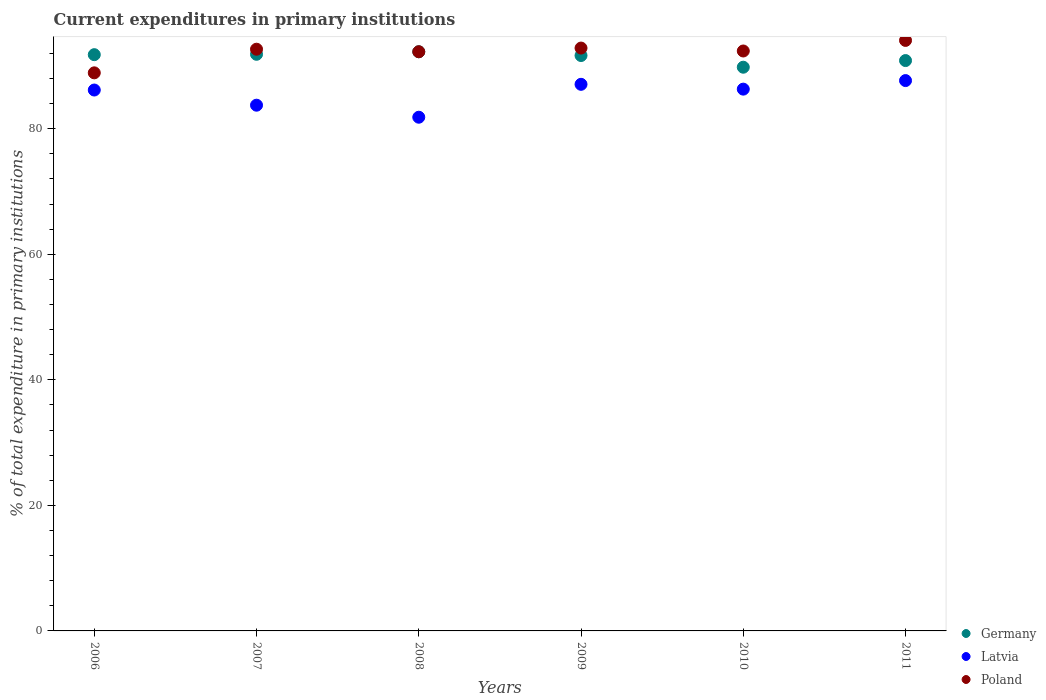Is the number of dotlines equal to the number of legend labels?
Give a very brief answer. Yes. What is the current expenditures in primary institutions in Germany in 2010?
Your answer should be very brief. 89.79. Across all years, what is the maximum current expenditures in primary institutions in Latvia?
Give a very brief answer. 87.66. Across all years, what is the minimum current expenditures in primary institutions in Poland?
Offer a very short reply. 88.89. What is the total current expenditures in primary institutions in Latvia in the graph?
Ensure brevity in your answer.  512.74. What is the difference between the current expenditures in primary institutions in Germany in 2010 and that in 2011?
Ensure brevity in your answer.  -1.06. What is the difference between the current expenditures in primary institutions in Poland in 2008 and the current expenditures in primary institutions in Latvia in 2009?
Provide a short and direct response. 5.19. What is the average current expenditures in primary institutions in Poland per year?
Offer a terse response. 92.18. In the year 2011, what is the difference between the current expenditures in primary institutions in Poland and current expenditures in primary institutions in Germany?
Your answer should be compact. 3.21. In how many years, is the current expenditures in primary institutions in Poland greater than 64 %?
Keep it short and to the point. 6. What is the ratio of the current expenditures in primary institutions in Germany in 2006 to that in 2008?
Offer a very short reply. 0.99. Is the difference between the current expenditures in primary institutions in Poland in 2006 and 2009 greater than the difference between the current expenditures in primary institutions in Germany in 2006 and 2009?
Keep it short and to the point. No. What is the difference between the highest and the second highest current expenditures in primary institutions in Latvia?
Your answer should be compact. 0.6. What is the difference between the highest and the lowest current expenditures in primary institutions in Poland?
Ensure brevity in your answer.  5.17. Is the sum of the current expenditures in primary institutions in Germany in 2006 and 2011 greater than the maximum current expenditures in primary institutions in Poland across all years?
Offer a very short reply. Yes. Does the current expenditures in primary institutions in Latvia monotonically increase over the years?
Make the answer very short. No. How many dotlines are there?
Your response must be concise. 3. What is the difference between two consecutive major ticks on the Y-axis?
Provide a succinct answer. 20. Where does the legend appear in the graph?
Give a very brief answer. Bottom right. How many legend labels are there?
Keep it short and to the point. 3. How are the legend labels stacked?
Offer a very short reply. Vertical. What is the title of the graph?
Offer a terse response. Current expenditures in primary institutions. What is the label or title of the Y-axis?
Offer a terse response. % of total expenditure in primary institutions. What is the % of total expenditure in primary institutions of Germany in 2006?
Your answer should be compact. 91.79. What is the % of total expenditure in primary institutions in Latvia in 2006?
Provide a succinct answer. 86.16. What is the % of total expenditure in primary institutions in Poland in 2006?
Offer a very short reply. 88.89. What is the % of total expenditure in primary institutions in Germany in 2007?
Provide a short and direct response. 91.85. What is the % of total expenditure in primary institutions of Latvia in 2007?
Keep it short and to the point. 83.74. What is the % of total expenditure in primary institutions in Poland in 2007?
Your answer should be compact. 92.66. What is the % of total expenditure in primary institutions of Germany in 2008?
Keep it short and to the point. 92.25. What is the % of total expenditure in primary institutions of Latvia in 2008?
Offer a very short reply. 81.82. What is the % of total expenditure in primary institutions of Poland in 2008?
Offer a terse response. 92.25. What is the % of total expenditure in primary institutions of Germany in 2009?
Provide a succinct answer. 91.65. What is the % of total expenditure in primary institutions in Latvia in 2009?
Offer a terse response. 87.06. What is the % of total expenditure in primary institutions in Poland in 2009?
Provide a succinct answer. 92.84. What is the % of total expenditure in primary institutions in Germany in 2010?
Your answer should be compact. 89.79. What is the % of total expenditure in primary institutions in Latvia in 2010?
Provide a short and direct response. 86.3. What is the % of total expenditure in primary institutions in Poland in 2010?
Ensure brevity in your answer.  92.37. What is the % of total expenditure in primary institutions of Germany in 2011?
Make the answer very short. 90.85. What is the % of total expenditure in primary institutions of Latvia in 2011?
Keep it short and to the point. 87.66. What is the % of total expenditure in primary institutions of Poland in 2011?
Provide a succinct answer. 94.06. Across all years, what is the maximum % of total expenditure in primary institutions of Germany?
Your answer should be compact. 92.25. Across all years, what is the maximum % of total expenditure in primary institutions in Latvia?
Offer a very short reply. 87.66. Across all years, what is the maximum % of total expenditure in primary institutions in Poland?
Your response must be concise. 94.06. Across all years, what is the minimum % of total expenditure in primary institutions of Germany?
Give a very brief answer. 89.79. Across all years, what is the minimum % of total expenditure in primary institutions in Latvia?
Offer a terse response. 81.82. Across all years, what is the minimum % of total expenditure in primary institutions of Poland?
Give a very brief answer. 88.89. What is the total % of total expenditure in primary institutions in Germany in the graph?
Offer a terse response. 548.17. What is the total % of total expenditure in primary institutions of Latvia in the graph?
Ensure brevity in your answer.  512.74. What is the total % of total expenditure in primary institutions in Poland in the graph?
Provide a succinct answer. 553.07. What is the difference between the % of total expenditure in primary institutions in Germany in 2006 and that in 2007?
Your response must be concise. -0.06. What is the difference between the % of total expenditure in primary institutions of Latvia in 2006 and that in 2007?
Keep it short and to the point. 2.42. What is the difference between the % of total expenditure in primary institutions of Poland in 2006 and that in 2007?
Provide a succinct answer. -3.76. What is the difference between the % of total expenditure in primary institutions in Germany in 2006 and that in 2008?
Give a very brief answer. -0.46. What is the difference between the % of total expenditure in primary institutions in Latvia in 2006 and that in 2008?
Provide a short and direct response. 4.33. What is the difference between the % of total expenditure in primary institutions in Poland in 2006 and that in 2008?
Offer a terse response. -3.36. What is the difference between the % of total expenditure in primary institutions of Germany in 2006 and that in 2009?
Your response must be concise. 0.14. What is the difference between the % of total expenditure in primary institutions of Latvia in 2006 and that in 2009?
Offer a very short reply. -0.91. What is the difference between the % of total expenditure in primary institutions of Poland in 2006 and that in 2009?
Make the answer very short. -3.95. What is the difference between the % of total expenditure in primary institutions of Germany in 2006 and that in 2010?
Your answer should be compact. 2. What is the difference between the % of total expenditure in primary institutions in Latvia in 2006 and that in 2010?
Your response must be concise. -0.14. What is the difference between the % of total expenditure in primary institutions in Poland in 2006 and that in 2010?
Ensure brevity in your answer.  -3.48. What is the difference between the % of total expenditure in primary institutions in Germany in 2006 and that in 2011?
Your answer should be compact. 0.94. What is the difference between the % of total expenditure in primary institutions in Latvia in 2006 and that in 2011?
Keep it short and to the point. -1.5. What is the difference between the % of total expenditure in primary institutions in Poland in 2006 and that in 2011?
Offer a very short reply. -5.17. What is the difference between the % of total expenditure in primary institutions of Germany in 2007 and that in 2008?
Give a very brief answer. -0.4. What is the difference between the % of total expenditure in primary institutions of Latvia in 2007 and that in 2008?
Ensure brevity in your answer.  1.92. What is the difference between the % of total expenditure in primary institutions of Poland in 2007 and that in 2008?
Make the answer very short. 0.4. What is the difference between the % of total expenditure in primary institutions in Germany in 2007 and that in 2009?
Give a very brief answer. 0.2. What is the difference between the % of total expenditure in primary institutions in Latvia in 2007 and that in 2009?
Provide a short and direct response. -3.32. What is the difference between the % of total expenditure in primary institutions of Poland in 2007 and that in 2009?
Give a very brief answer. -0.18. What is the difference between the % of total expenditure in primary institutions of Germany in 2007 and that in 2010?
Keep it short and to the point. 2.06. What is the difference between the % of total expenditure in primary institutions of Latvia in 2007 and that in 2010?
Ensure brevity in your answer.  -2.56. What is the difference between the % of total expenditure in primary institutions of Poland in 2007 and that in 2010?
Your response must be concise. 0.28. What is the difference between the % of total expenditure in primary institutions in Latvia in 2007 and that in 2011?
Offer a very short reply. -3.92. What is the difference between the % of total expenditure in primary institutions of Poland in 2007 and that in 2011?
Provide a short and direct response. -1.4. What is the difference between the % of total expenditure in primary institutions of Germany in 2008 and that in 2009?
Provide a succinct answer. 0.6. What is the difference between the % of total expenditure in primary institutions of Latvia in 2008 and that in 2009?
Offer a very short reply. -5.24. What is the difference between the % of total expenditure in primary institutions in Poland in 2008 and that in 2009?
Your answer should be compact. -0.58. What is the difference between the % of total expenditure in primary institutions in Germany in 2008 and that in 2010?
Your response must be concise. 2.46. What is the difference between the % of total expenditure in primary institutions of Latvia in 2008 and that in 2010?
Provide a succinct answer. -4.47. What is the difference between the % of total expenditure in primary institutions of Poland in 2008 and that in 2010?
Provide a short and direct response. -0.12. What is the difference between the % of total expenditure in primary institutions of Germany in 2008 and that in 2011?
Your answer should be compact. 1.4. What is the difference between the % of total expenditure in primary institutions of Latvia in 2008 and that in 2011?
Provide a short and direct response. -5.84. What is the difference between the % of total expenditure in primary institutions of Poland in 2008 and that in 2011?
Provide a short and direct response. -1.8. What is the difference between the % of total expenditure in primary institutions of Germany in 2009 and that in 2010?
Provide a succinct answer. 1.86. What is the difference between the % of total expenditure in primary institutions of Latvia in 2009 and that in 2010?
Offer a terse response. 0.77. What is the difference between the % of total expenditure in primary institutions of Poland in 2009 and that in 2010?
Give a very brief answer. 0.47. What is the difference between the % of total expenditure in primary institutions of Germany in 2009 and that in 2011?
Ensure brevity in your answer.  0.8. What is the difference between the % of total expenditure in primary institutions of Latvia in 2009 and that in 2011?
Provide a short and direct response. -0.6. What is the difference between the % of total expenditure in primary institutions of Poland in 2009 and that in 2011?
Offer a very short reply. -1.22. What is the difference between the % of total expenditure in primary institutions of Germany in 2010 and that in 2011?
Offer a terse response. -1.06. What is the difference between the % of total expenditure in primary institutions in Latvia in 2010 and that in 2011?
Make the answer very short. -1.36. What is the difference between the % of total expenditure in primary institutions in Poland in 2010 and that in 2011?
Give a very brief answer. -1.69. What is the difference between the % of total expenditure in primary institutions of Germany in 2006 and the % of total expenditure in primary institutions of Latvia in 2007?
Provide a short and direct response. 8.05. What is the difference between the % of total expenditure in primary institutions in Germany in 2006 and the % of total expenditure in primary institutions in Poland in 2007?
Provide a succinct answer. -0.87. What is the difference between the % of total expenditure in primary institutions in Latvia in 2006 and the % of total expenditure in primary institutions in Poland in 2007?
Your answer should be very brief. -6.5. What is the difference between the % of total expenditure in primary institutions of Germany in 2006 and the % of total expenditure in primary institutions of Latvia in 2008?
Give a very brief answer. 9.96. What is the difference between the % of total expenditure in primary institutions of Germany in 2006 and the % of total expenditure in primary institutions of Poland in 2008?
Make the answer very short. -0.47. What is the difference between the % of total expenditure in primary institutions in Latvia in 2006 and the % of total expenditure in primary institutions in Poland in 2008?
Provide a short and direct response. -6.1. What is the difference between the % of total expenditure in primary institutions in Germany in 2006 and the % of total expenditure in primary institutions in Latvia in 2009?
Your response must be concise. 4.72. What is the difference between the % of total expenditure in primary institutions in Germany in 2006 and the % of total expenditure in primary institutions in Poland in 2009?
Provide a succinct answer. -1.05. What is the difference between the % of total expenditure in primary institutions in Latvia in 2006 and the % of total expenditure in primary institutions in Poland in 2009?
Provide a succinct answer. -6.68. What is the difference between the % of total expenditure in primary institutions of Germany in 2006 and the % of total expenditure in primary institutions of Latvia in 2010?
Offer a very short reply. 5.49. What is the difference between the % of total expenditure in primary institutions of Germany in 2006 and the % of total expenditure in primary institutions of Poland in 2010?
Your answer should be compact. -0.59. What is the difference between the % of total expenditure in primary institutions of Latvia in 2006 and the % of total expenditure in primary institutions of Poland in 2010?
Your answer should be compact. -6.22. What is the difference between the % of total expenditure in primary institutions of Germany in 2006 and the % of total expenditure in primary institutions of Latvia in 2011?
Make the answer very short. 4.13. What is the difference between the % of total expenditure in primary institutions in Germany in 2006 and the % of total expenditure in primary institutions in Poland in 2011?
Keep it short and to the point. -2.27. What is the difference between the % of total expenditure in primary institutions in Latvia in 2006 and the % of total expenditure in primary institutions in Poland in 2011?
Offer a terse response. -7.9. What is the difference between the % of total expenditure in primary institutions in Germany in 2007 and the % of total expenditure in primary institutions in Latvia in 2008?
Your response must be concise. 10.02. What is the difference between the % of total expenditure in primary institutions in Germany in 2007 and the % of total expenditure in primary institutions in Poland in 2008?
Your answer should be very brief. -0.41. What is the difference between the % of total expenditure in primary institutions in Latvia in 2007 and the % of total expenditure in primary institutions in Poland in 2008?
Give a very brief answer. -8.51. What is the difference between the % of total expenditure in primary institutions of Germany in 2007 and the % of total expenditure in primary institutions of Latvia in 2009?
Offer a very short reply. 4.78. What is the difference between the % of total expenditure in primary institutions of Germany in 2007 and the % of total expenditure in primary institutions of Poland in 2009?
Offer a terse response. -0.99. What is the difference between the % of total expenditure in primary institutions of Latvia in 2007 and the % of total expenditure in primary institutions of Poland in 2009?
Offer a terse response. -9.1. What is the difference between the % of total expenditure in primary institutions in Germany in 2007 and the % of total expenditure in primary institutions in Latvia in 2010?
Provide a short and direct response. 5.55. What is the difference between the % of total expenditure in primary institutions of Germany in 2007 and the % of total expenditure in primary institutions of Poland in 2010?
Make the answer very short. -0.52. What is the difference between the % of total expenditure in primary institutions in Latvia in 2007 and the % of total expenditure in primary institutions in Poland in 2010?
Offer a terse response. -8.63. What is the difference between the % of total expenditure in primary institutions in Germany in 2007 and the % of total expenditure in primary institutions in Latvia in 2011?
Provide a succinct answer. 4.19. What is the difference between the % of total expenditure in primary institutions of Germany in 2007 and the % of total expenditure in primary institutions of Poland in 2011?
Give a very brief answer. -2.21. What is the difference between the % of total expenditure in primary institutions in Latvia in 2007 and the % of total expenditure in primary institutions in Poland in 2011?
Your answer should be very brief. -10.32. What is the difference between the % of total expenditure in primary institutions in Germany in 2008 and the % of total expenditure in primary institutions in Latvia in 2009?
Provide a short and direct response. 5.19. What is the difference between the % of total expenditure in primary institutions of Germany in 2008 and the % of total expenditure in primary institutions of Poland in 2009?
Offer a very short reply. -0.59. What is the difference between the % of total expenditure in primary institutions of Latvia in 2008 and the % of total expenditure in primary institutions of Poland in 2009?
Provide a short and direct response. -11.01. What is the difference between the % of total expenditure in primary institutions in Germany in 2008 and the % of total expenditure in primary institutions in Latvia in 2010?
Your response must be concise. 5.96. What is the difference between the % of total expenditure in primary institutions in Germany in 2008 and the % of total expenditure in primary institutions in Poland in 2010?
Your response must be concise. -0.12. What is the difference between the % of total expenditure in primary institutions in Latvia in 2008 and the % of total expenditure in primary institutions in Poland in 2010?
Give a very brief answer. -10.55. What is the difference between the % of total expenditure in primary institutions of Germany in 2008 and the % of total expenditure in primary institutions of Latvia in 2011?
Offer a terse response. 4.59. What is the difference between the % of total expenditure in primary institutions of Germany in 2008 and the % of total expenditure in primary institutions of Poland in 2011?
Give a very brief answer. -1.81. What is the difference between the % of total expenditure in primary institutions of Latvia in 2008 and the % of total expenditure in primary institutions of Poland in 2011?
Provide a succinct answer. -12.23. What is the difference between the % of total expenditure in primary institutions in Germany in 2009 and the % of total expenditure in primary institutions in Latvia in 2010?
Offer a terse response. 5.35. What is the difference between the % of total expenditure in primary institutions in Germany in 2009 and the % of total expenditure in primary institutions in Poland in 2010?
Offer a terse response. -0.72. What is the difference between the % of total expenditure in primary institutions of Latvia in 2009 and the % of total expenditure in primary institutions of Poland in 2010?
Provide a short and direct response. -5.31. What is the difference between the % of total expenditure in primary institutions in Germany in 2009 and the % of total expenditure in primary institutions in Latvia in 2011?
Keep it short and to the point. 3.99. What is the difference between the % of total expenditure in primary institutions of Germany in 2009 and the % of total expenditure in primary institutions of Poland in 2011?
Make the answer very short. -2.41. What is the difference between the % of total expenditure in primary institutions in Latvia in 2009 and the % of total expenditure in primary institutions in Poland in 2011?
Your response must be concise. -6.99. What is the difference between the % of total expenditure in primary institutions of Germany in 2010 and the % of total expenditure in primary institutions of Latvia in 2011?
Provide a succinct answer. 2.13. What is the difference between the % of total expenditure in primary institutions in Germany in 2010 and the % of total expenditure in primary institutions in Poland in 2011?
Make the answer very short. -4.27. What is the difference between the % of total expenditure in primary institutions in Latvia in 2010 and the % of total expenditure in primary institutions in Poland in 2011?
Make the answer very short. -7.76. What is the average % of total expenditure in primary institutions in Germany per year?
Provide a succinct answer. 91.36. What is the average % of total expenditure in primary institutions of Latvia per year?
Make the answer very short. 85.46. What is the average % of total expenditure in primary institutions of Poland per year?
Your response must be concise. 92.18. In the year 2006, what is the difference between the % of total expenditure in primary institutions of Germany and % of total expenditure in primary institutions of Latvia?
Offer a terse response. 5.63. In the year 2006, what is the difference between the % of total expenditure in primary institutions of Germany and % of total expenditure in primary institutions of Poland?
Ensure brevity in your answer.  2.89. In the year 2006, what is the difference between the % of total expenditure in primary institutions of Latvia and % of total expenditure in primary institutions of Poland?
Make the answer very short. -2.74. In the year 2007, what is the difference between the % of total expenditure in primary institutions of Germany and % of total expenditure in primary institutions of Latvia?
Offer a very short reply. 8.11. In the year 2007, what is the difference between the % of total expenditure in primary institutions of Germany and % of total expenditure in primary institutions of Poland?
Keep it short and to the point. -0.81. In the year 2007, what is the difference between the % of total expenditure in primary institutions in Latvia and % of total expenditure in primary institutions in Poland?
Offer a very short reply. -8.92. In the year 2008, what is the difference between the % of total expenditure in primary institutions in Germany and % of total expenditure in primary institutions in Latvia?
Give a very brief answer. 10.43. In the year 2008, what is the difference between the % of total expenditure in primary institutions in Germany and % of total expenditure in primary institutions in Poland?
Make the answer very short. -0. In the year 2008, what is the difference between the % of total expenditure in primary institutions in Latvia and % of total expenditure in primary institutions in Poland?
Your answer should be compact. -10.43. In the year 2009, what is the difference between the % of total expenditure in primary institutions in Germany and % of total expenditure in primary institutions in Latvia?
Offer a very short reply. 4.59. In the year 2009, what is the difference between the % of total expenditure in primary institutions in Germany and % of total expenditure in primary institutions in Poland?
Provide a short and direct response. -1.19. In the year 2009, what is the difference between the % of total expenditure in primary institutions in Latvia and % of total expenditure in primary institutions in Poland?
Keep it short and to the point. -5.77. In the year 2010, what is the difference between the % of total expenditure in primary institutions of Germany and % of total expenditure in primary institutions of Latvia?
Provide a short and direct response. 3.49. In the year 2010, what is the difference between the % of total expenditure in primary institutions in Germany and % of total expenditure in primary institutions in Poland?
Your answer should be very brief. -2.58. In the year 2010, what is the difference between the % of total expenditure in primary institutions of Latvia and % of total expenditure in primary institutions of Poland?
Your response must be concise. -6.08. In the year 2011, what is the difference between the % of total expenditure in primary institutions of Germany and % of total expenditure in primary institutions of Latvia?
Offer a very short reply. 3.19. In the year 2011, what is the difference between the % of total expenditure in primary institutions of Germany and % of total expenditure in primary institutions of Poland?
Make the answer very short. -3.21. In the year 2011, what is the difference between the % of total expenditure in primary institutions in Latvia and % of total expenditure in primary institutions in Poland?
Your answer should be very brief. -6.4. What is the ratio of the % of total expenditure in primary institutions in Germany in 2006 to that in 2007?
Offer a terse response. 1. What is the ratio of the % of total expenditure in primary institutions in Latvia in 2006 to that in 2007?
Keep it short and to the point. 1.03. What is the ratio of the % of total expenditure in primary institutions of Poland in 2006 to that in 2007?
Your answer should be very brief. 0.96. What is the ratio of the % of total expenditure in primary institutions of Germany in 2006 to that in 2008?
Your response must be concise. 0.99. What is the ratio of the % of total expenditure in primary institutions in Latvia in 2006 to that in 2008?
Offer a terse response. 1.05. What is the ratio of the % of total expenditure in primary institutions of Poland in 2006 to that in 2008?
Your response must be concise. 0.96. What is the ratio of the % of total expenditure in primary institutions in Germany in 2006 to that in 2009?
Your response must be concise. 1. What is the ratio of the % of total expenditure in primary institutions of Poland in 2006 to that in 2009?
Provide a succinct answer. 0.96. What is the ratio of the % of total expenditure in primary institutions of Germany in 2006 to that in 2010?
Provide a succinct answer. 1.02. What is the ratio of the % of total expenditure in primary institutions of Poland in 2006 to that in 2010?
Give a very brief answer. 0.96. What is the ratio of the % of total expenditure in primary institutions in Germany in 2006 to that in 2011?
Keep it short and to the point. 1.01. What is the ratio of the % of total expenditure in primary institutions in Latvia in 2006 to that in 2011?
Your response must be concise. 0.98. What is the ratio of the % of total expenditure in primary institutions in Poland in 2006 to that in 2011?
Make the answer very short. 0.95. What is the ratio of the % of total expenditure in primary institutions of Germany in 2007 to that in 2008?
Keep it short and to the point. 1. What is the ratio of the % of total expenditure in primary institutions of Latvia in 2007 to that in 2008?
Provide a short and direct response. 1.02. What is the ratio of the % of total expenditure in primary institutions in Poland in 2007 to that in 2008?
Make the answer very short. 1. What is the ratio of the % of total expenditure in primary institutions of Latvia in 2007 to that in 2009?
Make the answer very short. 0.96. What is the ratio of the % of total expenditure in primary institutions in Germany in 2007 to that in 2010?
Your answer should be compact. 1.02. What is the ratio of the % of total expenditure in primary institutions of Latvia in 2007 to that in 2010?
Your answer should be very brief. 0.97. What is the ratio of the % of total expenditure in primary institutions in Germany in 2007 to that in 2011?
Your answer should be compact. 1.01. What is the ratio of the % of total expenditure in primary institutions in Latvia in 2007 to that in 2011?
Your answer should be very brief. 0.96. What is the ratio of the % of total expenditure in primary institutions in Poland in 2007 to that in 2011?
Provide a short and direct response. 0.99. What is the ratio of the % of total expenditure in primary institutions of Germany in 2008 to that in 2009?
Provide a succinct answer. 1.01. What is the ratio of the % of total expenditure in primary institutions of Latvia in 2008 to that in 2009?
Your answer should be compact. 0.94. What is the ratio of the % of total expenditure in primary institutions in Poland in 2008 to that in 2009?
Offer a very short reply. 0.99. What is the ratio of the % of total expenditure in primary institutions in Germany in 2008 to that in 2010?
Give a very brief answer. 1.03. What is the ratio of the % of total expenditure in primary institutions in Latvia in 2008 to that in 2010?
Provide a succinct answer. 0.95. What is the ratio of the % of total expenditure in primary institutions of Germany in 2008 to that in 2011?
Make the answer very short. 1.02. What is the ratio of the % of total expenditure in primary institutions in Latvia in 2008 to that in 2011?
Give a very brief answer. 0.93. What is the ratio of the % of total expenditure in primary institutions in Poland in 2008 to that in 2011?
Keep it short and to the point. 0.98. What is the ratio of the % of total expenditure in primary institutions in Germany in 2009 to that in 2010?
Give a very brief answer. 1.02. What is the ratio of the % of total expenditure in primary institutions of Latvia in 2009 to that in 2010?
Offer a very short reply. 1.01. What is the ratio of the % of total expenditure in primary institutions of Poland in 2009 to that in 2010?
Offer a terse response. 1. What is the ratio of the % of total expenditure in primary institutions of Germany in 2009 to that in 2011?
Provide a succinct answer. 1.01. What is the ratio of the % of total expenditure in primary institutions in Germany in 2010 to that in 2011?
Give a very brief answer. 0.99. What is the ratio of the % of total expenditure in primary institutions in Latvia in 2010 to that in 2011?
Your answer should be compact. 0.98. What is the ratio of the % of total expenditure in primary institutions in Poland in 2010 to that in 2011?
Give a very brief answer. 0.98. What is the difference between the highest and the second highest % of total expenditure in primary institutions of Germany?
Your answer should be very brief. 0.4. What is the difference between the highest and the second highest % of total expenditure in primary institutions in Latvia?
Make the answer very short. 0.6. What is the difference between the highest and the second highest % of total expenditure in primary institutions of Poland?
Keep it short and to the point. 1.22. What is the difference between the highest and the lowest % of total expenditure in primary institutions of Germany?
Ensure brevity in your answer.  2.46. What is the difference between the highest and the lowest % of total expenditure in primary institutions of Latvia?
Your answer should be very brief. 5.84. What is the difference between the highest and the lowest % of total expenditure in primary institutions of Poland?
Make the answer very short. 5.17. 